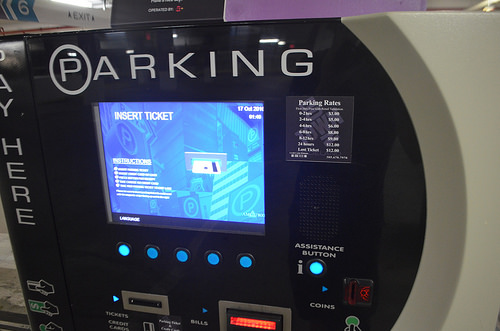<image>
Can you confirm if the machine is next to the screen? No. The machine is not positioned next to the screen. They are located in different areas of the scene. Is there a machine on the floor? Yes. Looking at the image, I can see the machine is positioned on top of the floor, with the floor providing support. 